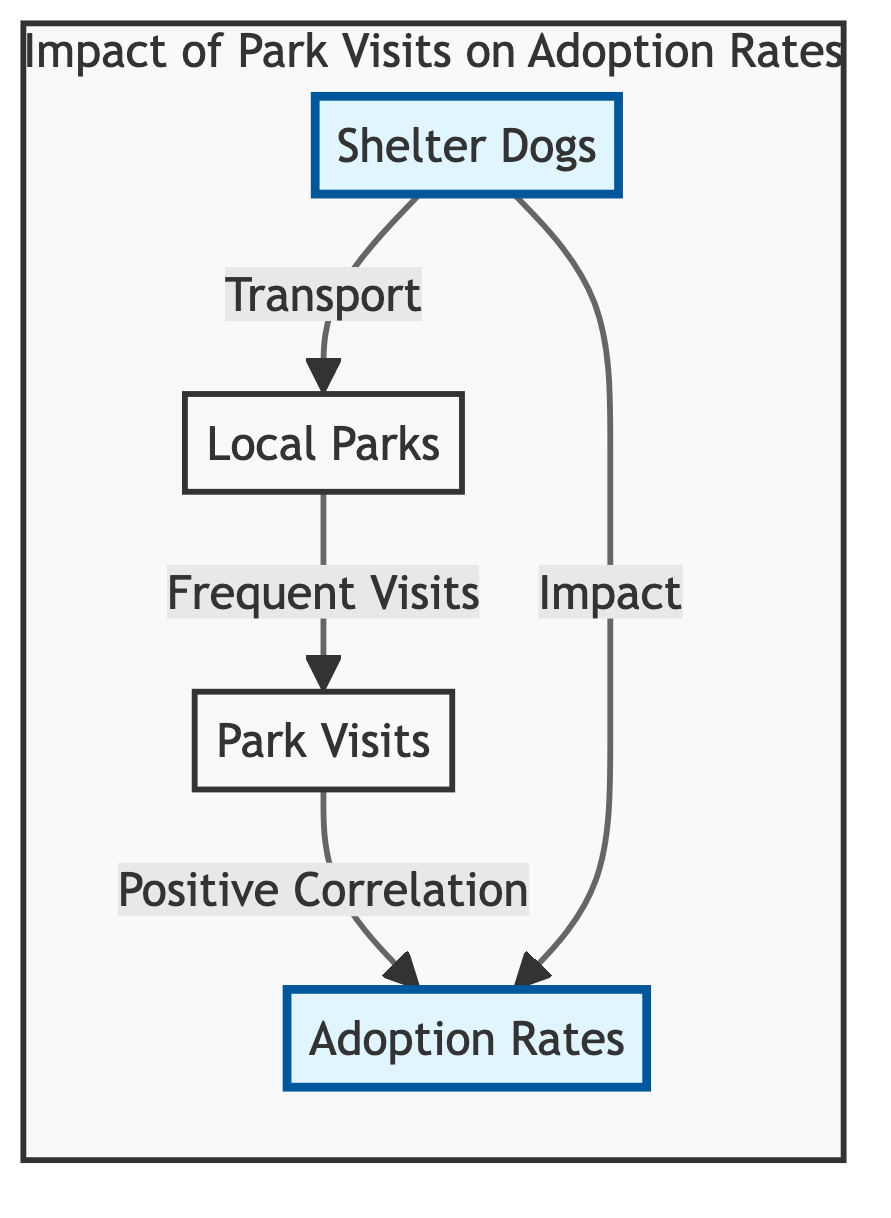What is the first node in the diagram? The first node in the diagram is identified as "Shelter Dogs," which is the starting point of the flowchart.
Answer: Shelter Dogs How many nodes are in the diagram? By counting all the unique points represented in the diagram, there are four nodes: Shelter Dogs, Local Parks, Adoption Rates, and Park Visits.
Answer: Four What do Local Parks influence in the diagram? The Local Parks node connects to the Park Visits node, indicating that Local Parks influence the frequency of Park Visits.
Answer: Park Visits What is the relationship between Park Visits and Adoption Rates? In the diagram, the Park Visits node has a directed connection to the Adoption Rates, indicating a positive correlation, which suggests that more park visits can lead to increased adoption rates.
Answer: Positive Correlation What is the impact of Shelter Dogs on Adoption Rates? The Shelter Dogs node has a direct relationship that shows it has an impact on Adoption Rates. This infers that the number of shelter dogs can affect the rate at which dogs are adopted.
Answer: Impact How do Park Visits relate to the influence of Shelter Dogs? The Park Visits node is indirectly influenced by Shelter Dogs through the Local Parks node, which highlights that transporting shelter dogs to the park leads to park visits, correlating with adoption rates.
Answer: Indirect Influence What is the focus area of the subgraph? The subgraph titled "Impact of Park Visits on Adoption Rates" encompasses the relationship between Shelter Dogs, Local Parks, Adoption Rates, and Park Visits, indicating its focus.
Answer: Impact of Park Visits on Adoption Rates Which node indicates a frequent activity involving Shelter Dogs? The Local Parks node indicates a frequent activity involving Shelter Dogs, as it is linked to the transport of shelter dogs to the local parks for visits.
Answer: Local Parks How are Shelter Dogs connected to both Park Visits and Adoption Rates? The Shelter Dogs node is directly connected to both the Park Visits (through Local Parks) and Adoption Rates, indicating a flow where shelter dogs lead to park visits, which then correlate with increased adoption rates.
Answer: Both Park Visits and Adoption Rates 